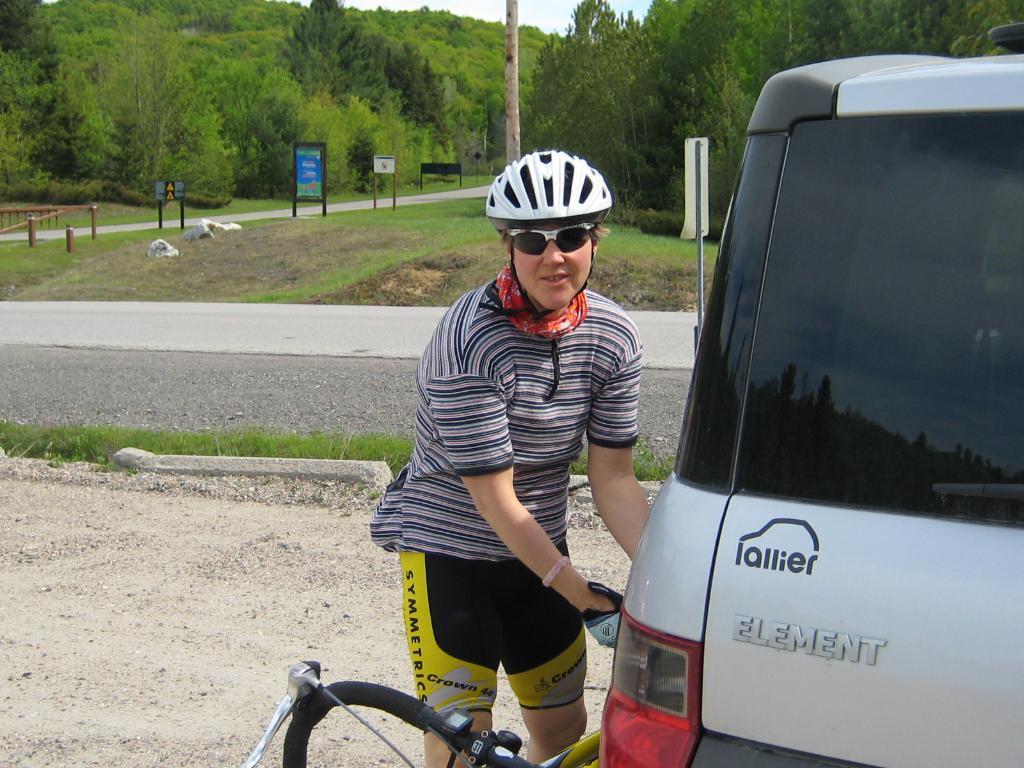Could you give a brief overview of what you see in this image? Here on the right side we can see a vehicle,bicycle and a person standing on the ground and there is a helmet on the head. In the background there are trees,grass,road,hoardings and sky. 